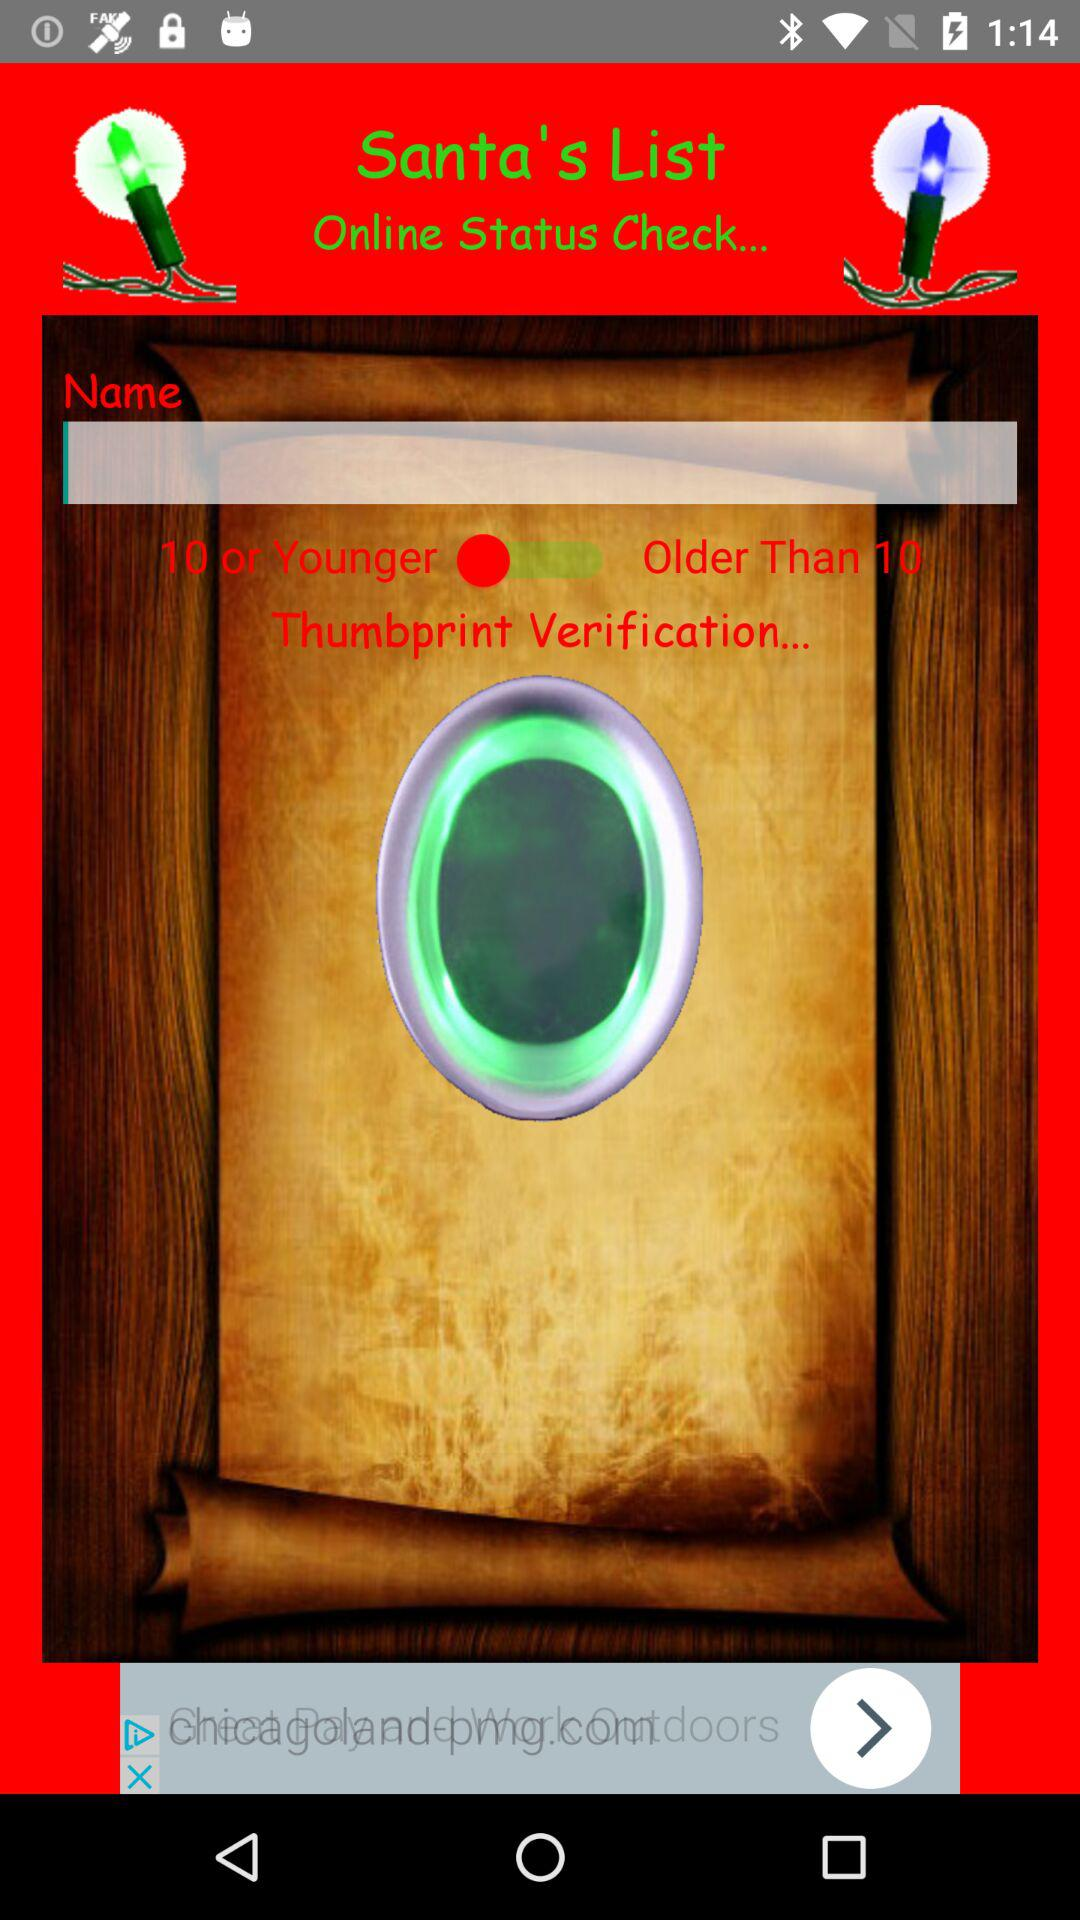What is the name of the application? The name of the application is "Santa's List". 